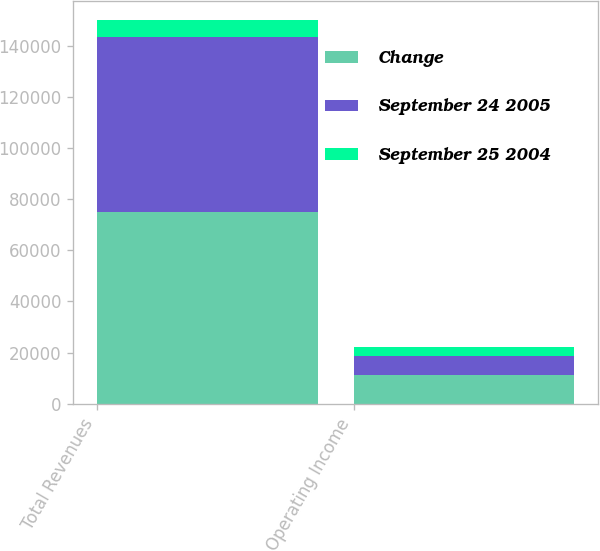Convert chart. <chart><loc_0><loc_0><loc_500><loc_500><stacked_bar_chart><ecel><fcel>Total Revenues<fcel>Operating Income<nl><fcel>Change<fcel>74957<fcel>11175<nl><fcel>September 24 2005<fcel>68483<fcel>7500<nl><fcel>September 25 2004<fcel>6474<fcel>3675<nl></chart> 